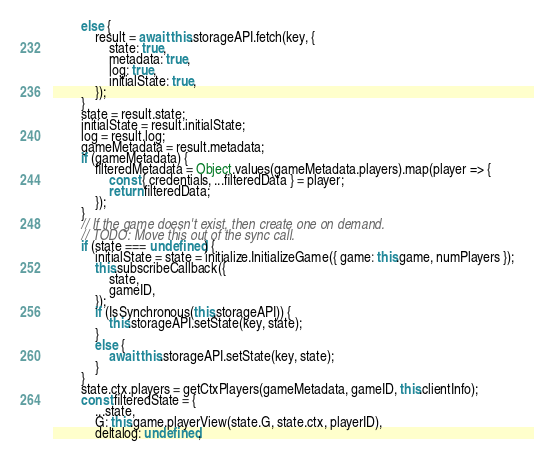<code> <loc_0><loc_0><loc_500><loc_500><_JavaScript_>        else {
            result = await this.storageAPI.fetch(key, {
                state: true,
                metadata: true,
                log: true,
                initialState: true,
            });
        }
        state = result.state;
        initialState = result.initialState;
        log = result.log;
        gameMetadata = result.metadata;
        if (gameMetadata) {
            filteredMetadata = Object.values(gameMetadata.players).map(player => {
                const { credentials, ...filteredData } = player;
                return filteredData;
            });
        }
        // If the game doesn't exist, then create one on demand.
        // TODO: Move this out of the sync call.
        if (state === undefined) {
            initialState = state = initialize.InitializeGame({ game: this.game, numPlayers });
            this.subscribeCallback({
                state,
                gameID,
            });
            if (IsSynchronous(this.storageAPI)) {
                this.storageAPI.setState(key, state);
            }
            else {
                await this.storageAPI.setState(key, state);
            }
        }
        state.ctx.players = getCtxPlayers(gameMetadata, gameID, this.clientInfo);
        const filteredState = {
            ...state,
            G: this.game.playerView(state.G, state.ctx, playerID),
            deltalog: undefined,</code> 